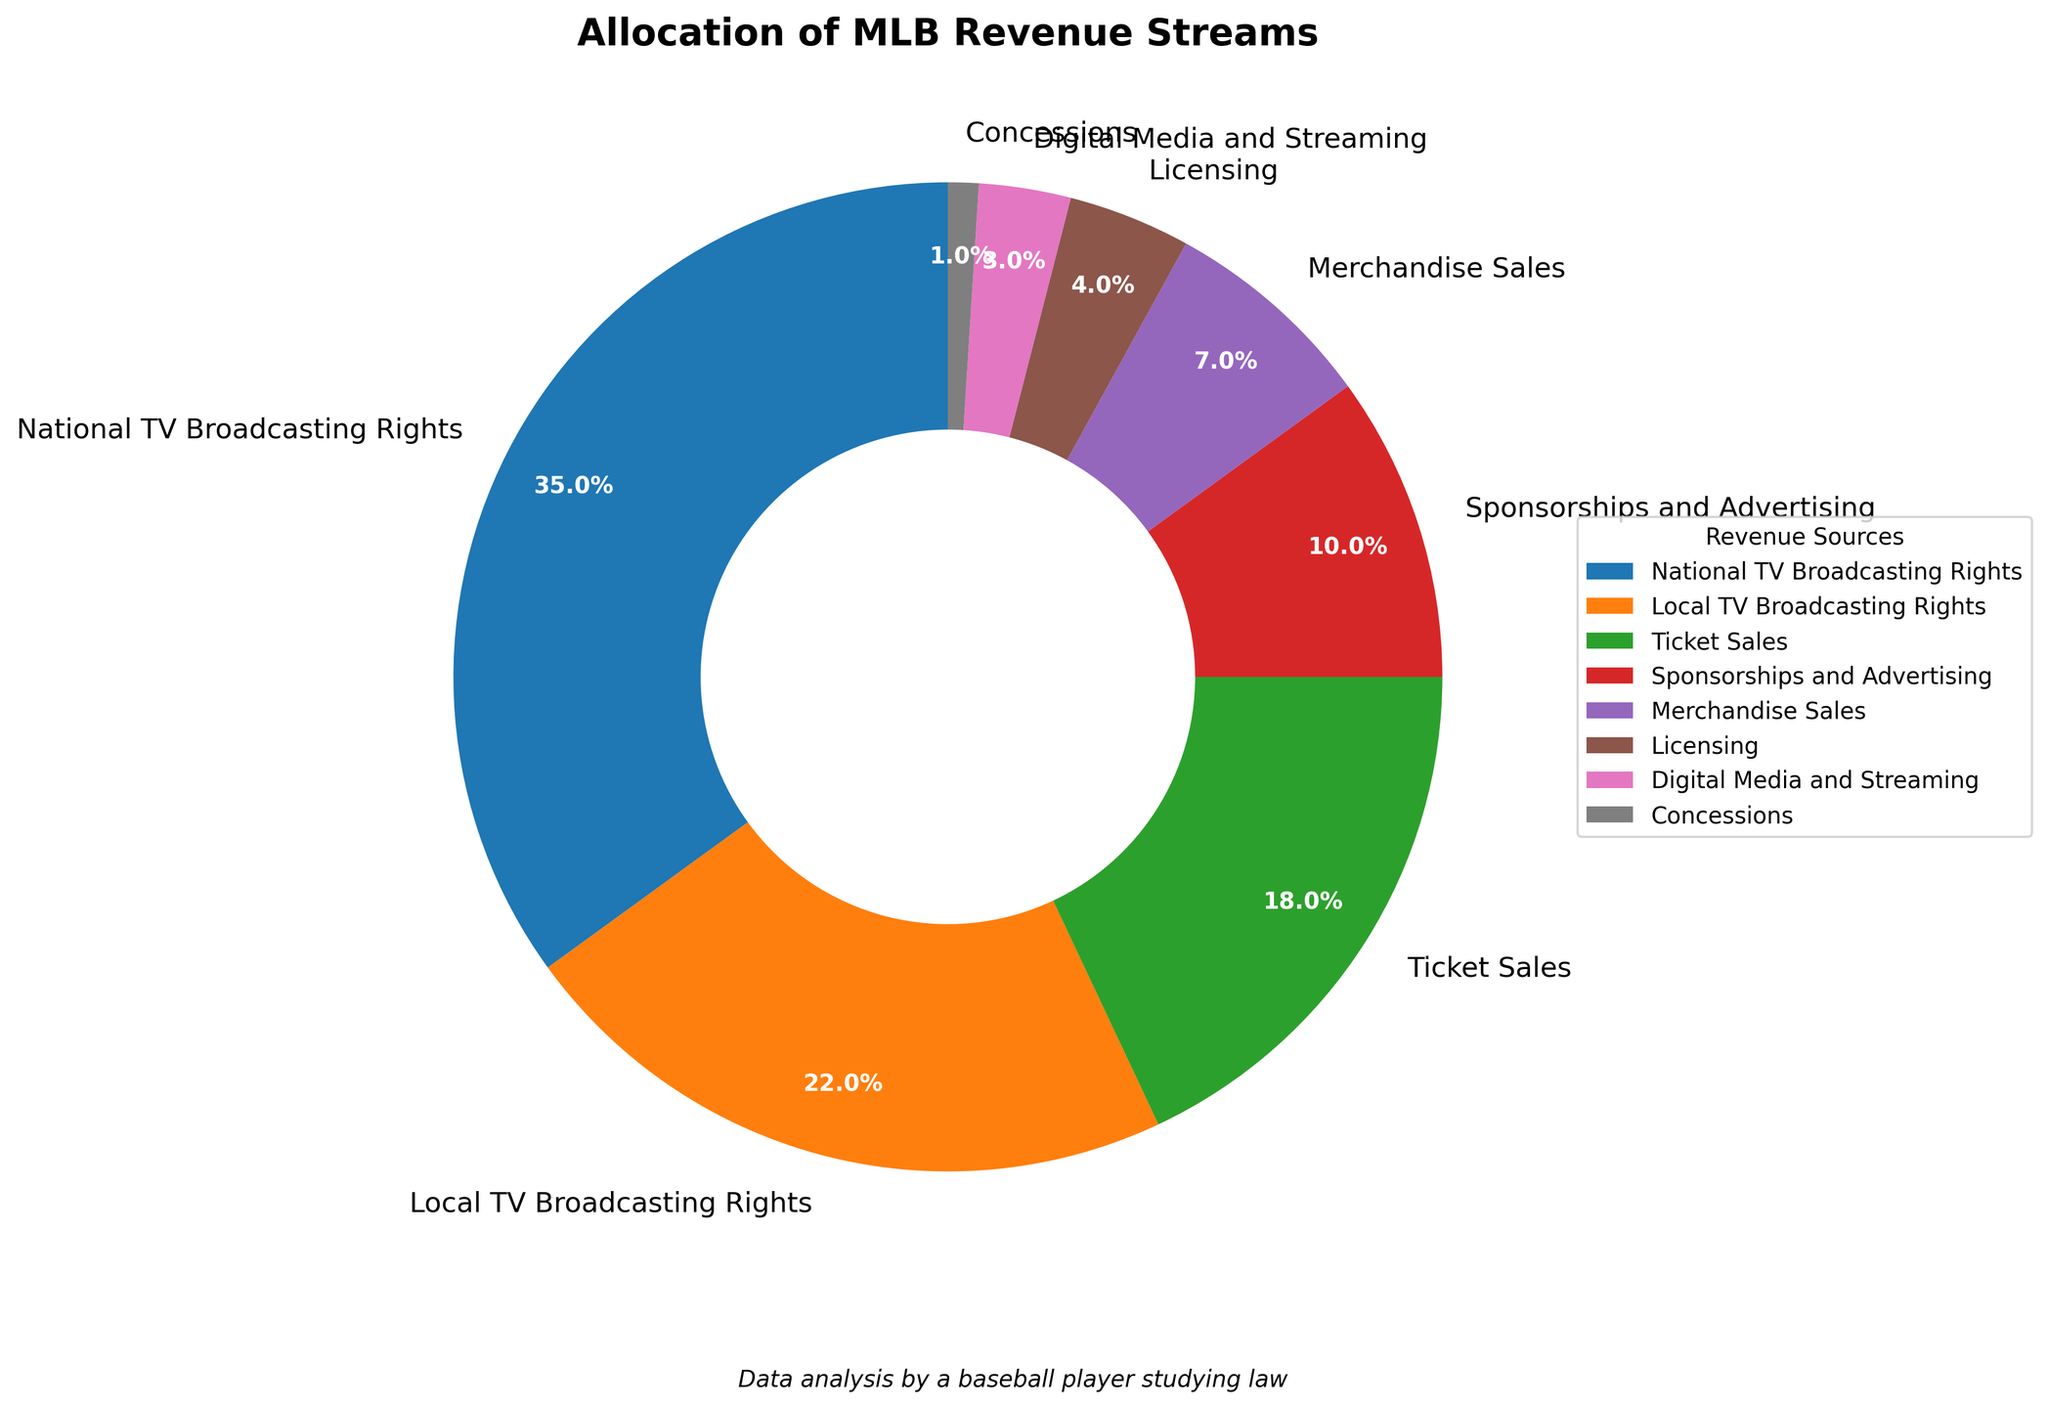What's the revenue percentage from ticket sales? Identify the label "Ticket Sales" in the pie chart and refer to the associated percentage value.
Answer: 18% Which revenue source contributes more, local TV broadcasting rights or national TV broadcasting rights? Compare the percentage values of "Local TV Broadcasting Rights" (22%) and "National TV Broadcasting Rights" (35%) shown in the pie chart.
Answer: National TV Broadcasting Rights What's the total revenue percentage generated by merchandise sales, licensing, and concessions combined? Add the percentage values of "Merchandise Sales" (7%), "Licensing" (4%), and "Concessions" (1%) from the pie chart to find the combined total. 7 + 4 + 1 = 12
Answer: 12% Is the percentage from digital media and streaming higher than that from concessions? Compare the percentage values for "Digital Media and Streaming" (3%) and "Concessions" (1%) in the pie chart.
Answer: Yes How much smaller is the revenue percentage from sponsorships and advertising compared to local TV broadcasting rights? Determine the difference between the percentage values of "Sponsorships and Advertising" (10%) and "Local TV Broadcasting Rights" (22%). 22 - 10 = 12
Answer: 12% Which two revenue sources contribute equally to the total revenue? Identify which labels have the same percentage values in the pie chart. However, in this chart, no two sources have the same percentage.
Answer: None What is the sum of the revenue percentages from ticket sales, and national TV broadcasting rights? Add the percentage values from "Ticket Sales" (18%) and "National TV Broadcasting Rights" (35%). 18 + 35 = 53
Answer: 53% Rank the revenue sources from most to least significant contribution. List the revenue sources based on their percentage values from highest to lowest: National TV Broadcasting Rights (35%), Local TV Broadcasting Rights (22%), Ticket Sales (18%), Sponsorships and Advertising (10%), Merchandise Sales (7%), Licensing (4%), Digital Media and Streaming (3%), Concessions (1%).
Answer: National TV Broadcasting Rights, Local TV Broadcasting Rights, Ticket Sales, Sponsorships and Advertising, Merchandise Sales, Licensing, Digital Media and Streaming, Concessions What percentage of the revenue comes from non-media sources (Ticket Sales, Sponsorships and Advertising, Merchandise Sales, Licensing, Concessions)? Add the percentage values of the revenue sources that are non-media: "Ticket Sales" (18%), "Sponsorships and Advertising" (10%), "Merchandise Sales" (7%), "Licensing" (4%), "Concessions" (1%). 18 + 10 + 7 + 4 + 1 = 40
Answer: 40% 